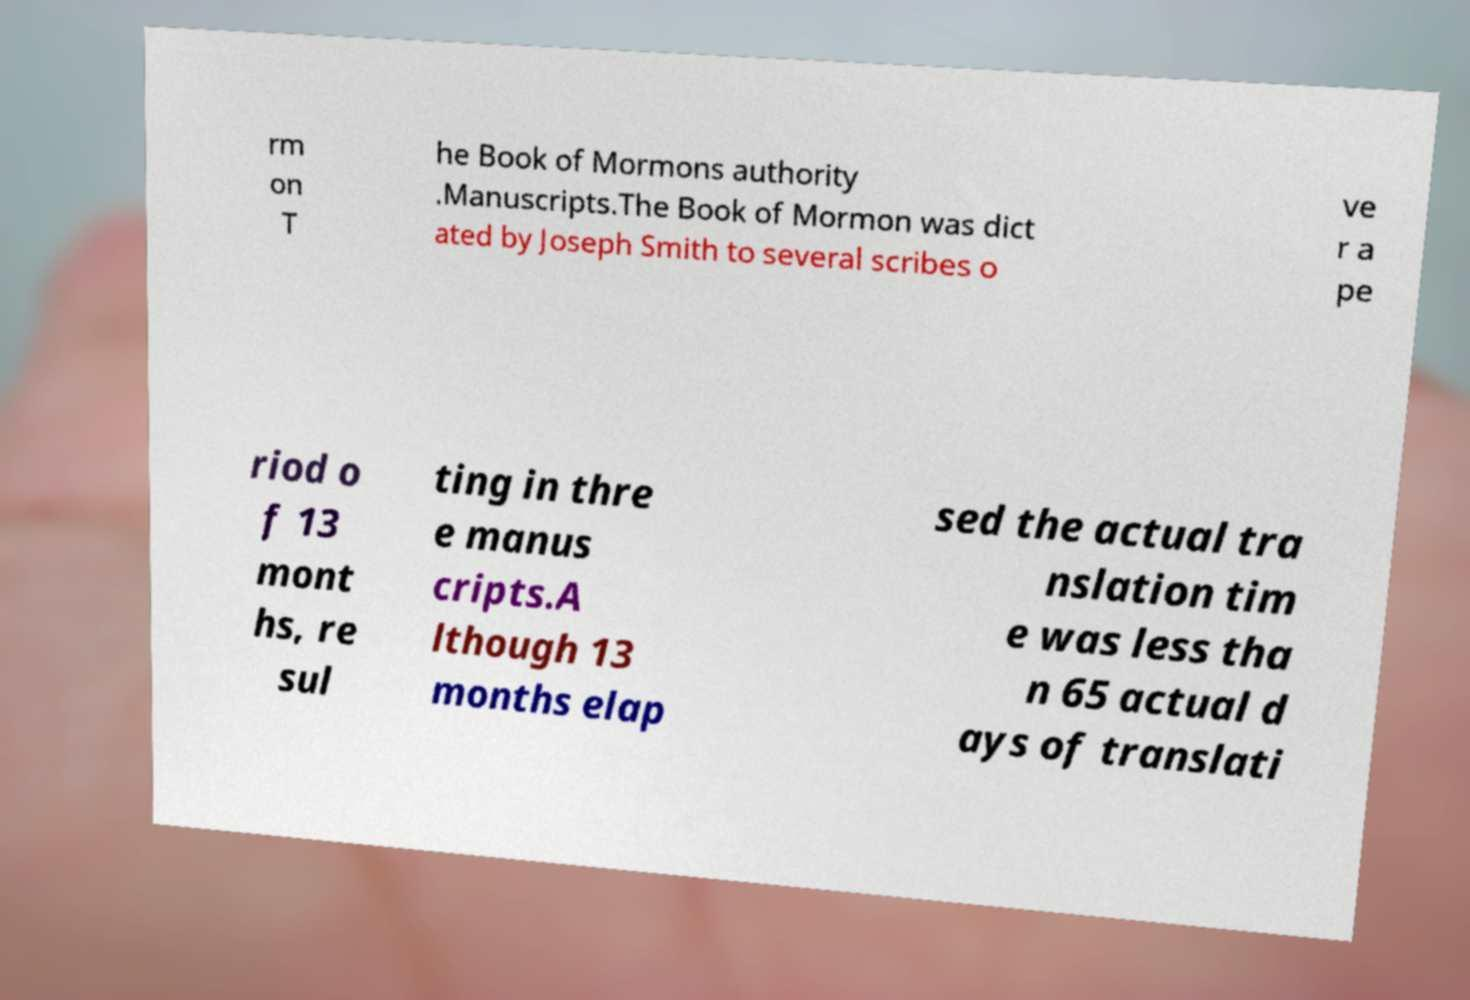Please identify and transcribe the text found in this image. rm on T he Book of Mormons authority .Manuscripts.The Book of Mormon was dict ated by Joseph Smith to several scribes o ve r a pe riod o f 13 mont hs, re sul ting in thre e manus cripts.A lthough 13 months elap sed the actual tra nslation tim e was less tha n 65 actual d ays of translati 